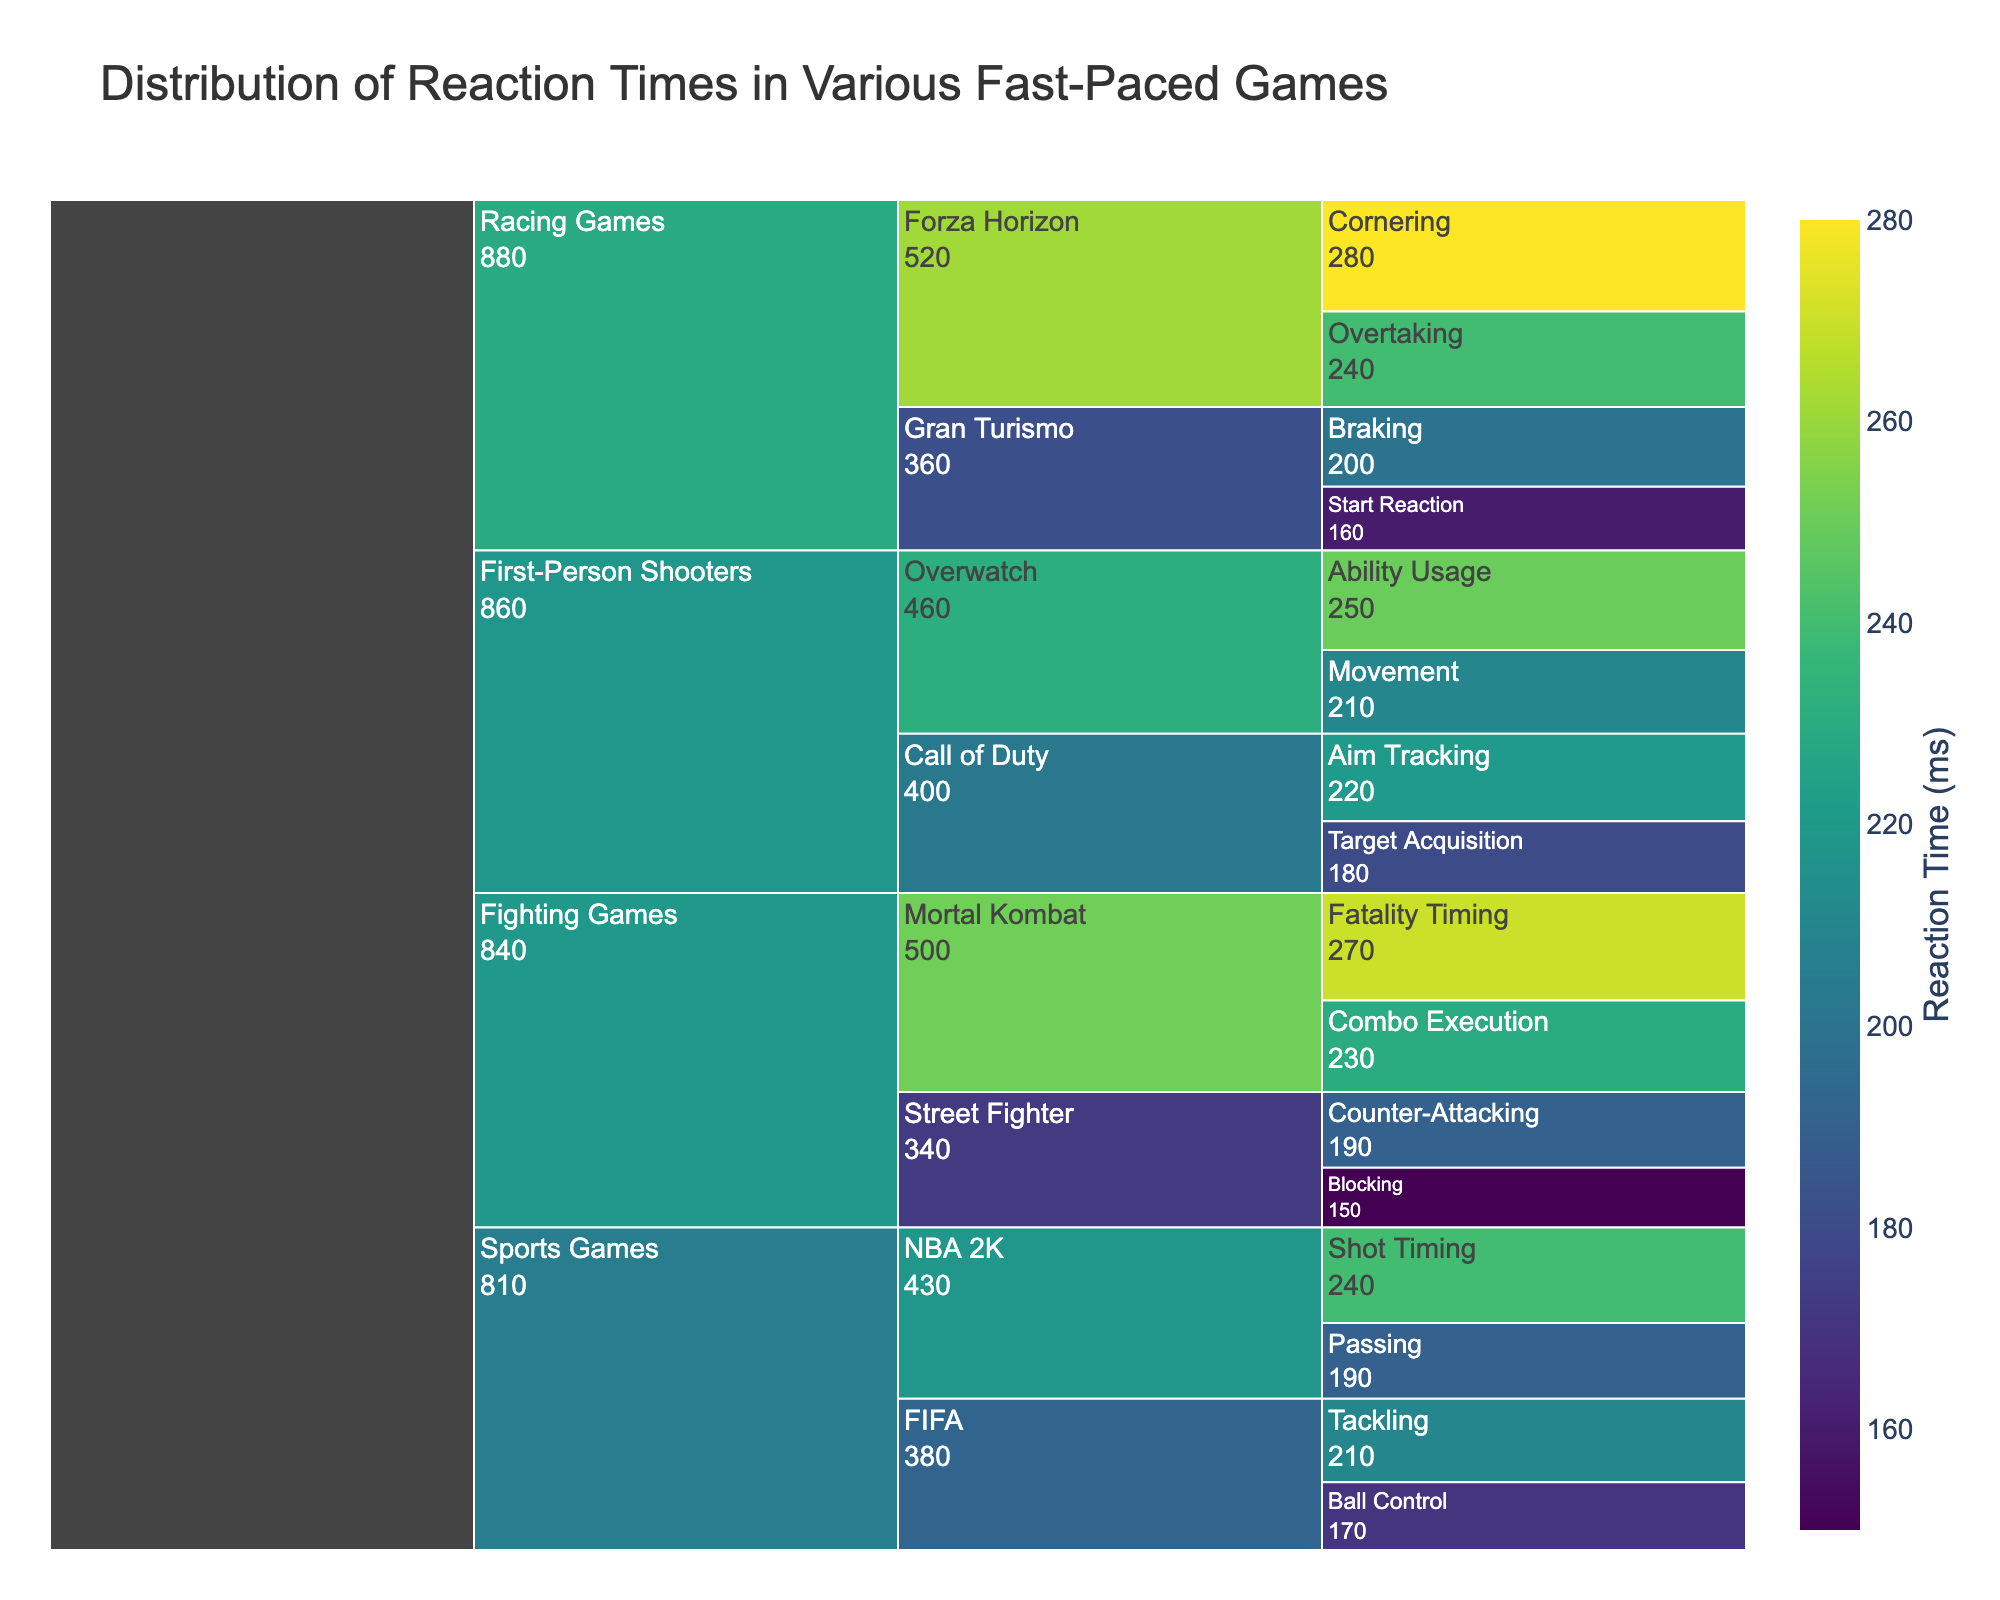What's the title of the chart? The title of the chart is usually displayed at the top of the figure. For this figure, it is set in the code provided.
Answer: Distribution of Reaction Times in Various Fast-Paced Games Which game category has the fastest reaction time? By examining the chart, one can identify the smallest value in the 'Reaction Time (ms)' category and trace it back to its respective game category.
Answer: Fighting Games What is the reaction time for Aim Tracking in Call of Duty? Locate the 'First-Person Shooters' game category, then find 'Call of Duty', and within that, locate the 'Aim Tracking' sub-category. The associated reaction time value is displayed in the chart.
Answer: 220 ms Which sub-category in Racing Games has the highest reaction time? Navigate to the 'Racing Games' category and compare the reaction times listed for each sub-category. The largest value corresponds to the sub-category.
Answer: Cornering What is the average reaction time for the sub-categories in the Fighting Games category? Identify the reaction times for all sub-categories within the 'Fighting Games' category and calculate the average. The sub-categories and their reaction times are: Blocking (150ms), Counter-Attacking (190ms), Combo Execution (230ms), and Fatality Timing (270ms). The average is (150 + 190 + 230 + 270) / 4.
Answer: 210 ms Which sub-category in Sports Games has the closest reaction time to 200 ms? Look at the 'Sports Games' category and identify the sub-category with the reaction time value closest to 200 ms by comparing all the values listed.
Answer: Tackling How many sub-categories have reaction times greater than 250 ms? Go through each category and sub-category, noting the reaction times. Count how many of them have values higher than 250 ms. The sub-categories 'Overwatch' (Ability Usage), 'Mortal Kombat' (Fatality Timing), and 'Forza Horizon' (Cornering) have reaction times greater than 250 ms.
Answer: 3 What is the difference in reaction times between Braking in Gran Turismo and Target Acquisition in Call of Duty? Locate the reaction times for these two sub-categories within their respective categories: Braking in Gran Turismo (200 ms) and Target Acquisition in Call of Duty (180 ms). Subtract the smaller value from the larger value: 200 - 180.
Answer: 20 ms Which game in the First-Person Shooters category has a higher reaction time: Call of Duty or Overwatch? Compare the cumulative reaction times for each sub-category under 'Call of Duty' and 'Overwatch'. Call of Duty has sub-categories Aim Tracking (220 ms) and Target Acquisition (180 ms), while Overwatch has Ability Usage (250 ms) and Movement (210 ms). The cumulative totals are: Call of Duty (220 + 180 = 400 ms) and Overwatch (250 + 210 = 460 ms).
Answer: Overwatch What is the median reaction time for the sub-categories within First-Person Shooters? Identify all the reaction times in the 'First-Person Shooters' category: Aim Tracking (220 ms), Target Acquisition (180 ms), Ability Usage (250 ms), and Movement (210 ms). Arrange them in order: 180, 210, 220, 250. The median value is the average of the two middle numbers: (210 + 220) / 2.
Answer: 215 ms 